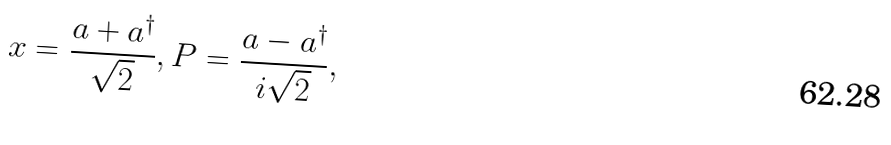<formula> <loc_0><loc_0><loc_500><loc_500>x = \frac { a + a ^ { \dagger } } { \sqrt { 2 } } , P = \frac { a - a ^ { \dagger } } { i \sqrt { 2 } } ,</formula> 